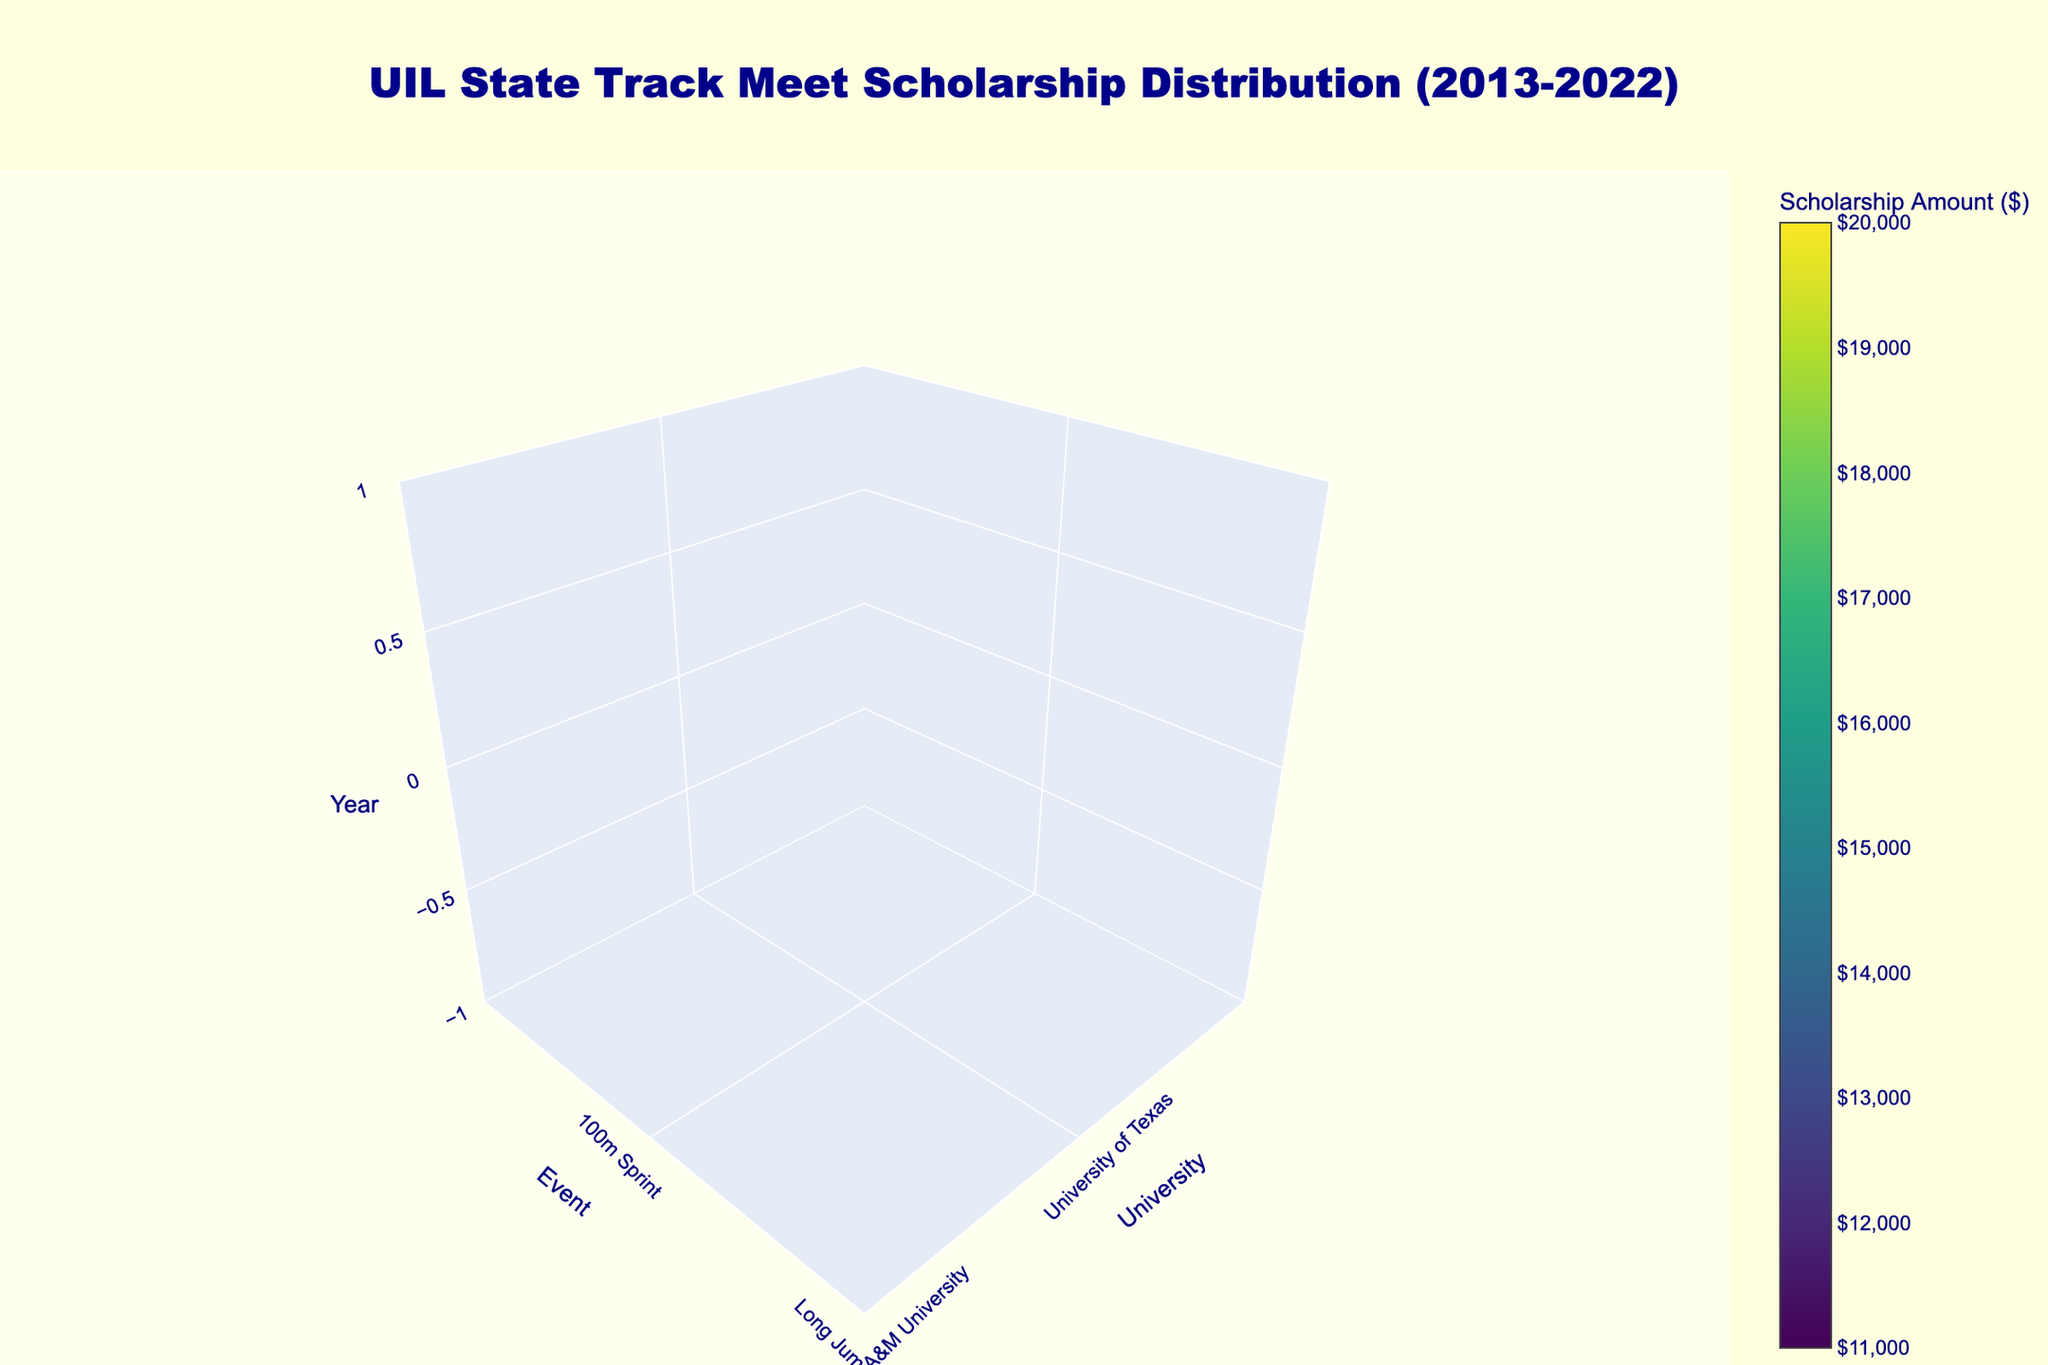What is the title of the 3D volume plot? The title is found at the top of the figure, prominently displayed in a larger font for immediate visibility.
Answer: UIL State Track Meet Scholarship Distribution (2013-2022) What are the labeled axes on the plot? The axes are labeled to give context to the data being displayed. Look at the labels near the axis lines.
Answer: University, Event, Year What is the range of scholarship amounts shown on the colorbar? The colorbar is located on the side of the plot and represents the distribution of scholarship amounts using colors.
Answer: $11,000 to $20,000 Which university awarded the highest scholarship amount shown in the plot? Look for the scholarship amount on the colorbar with the highest value and trace it to the corresponding university.
Answer: University of Houston Which event had scholarships awarded in 2019? Locate the year 2019 on the z-axis, and follow horizontally across to find the corresponding event.
Answer: Pole Vault How many universities are represented in the plot? Count the number of unique universities displayed on the x-axis.
Answer: 10 What is the scholarship amount awarded for the 400m Hurdles event in 2016? Locate the event '400m Hurdles' and trace it to the year 2016. Refer to the color of the point to determine the value from the colorbar.
Answer: $20,000 How does the scholarship amount for the Long Jump in 2014 compare to the scholarship for the Discus Throw in 2021? Identify the scholarship amounts for both years and events, then compare the values. The color mapping on the plot will help indicate this.
Answer: $18,000 for Long Jump, $19,000 for Discus Throw, Discus Throw is higher by $1,000 Which year granted the lowest scholarship amount, and what was the amount? Identify the lowest value on the colorbar and locate it on the z-axis to determine the corresponding year and amount.
Answer: 2022, $11,000 